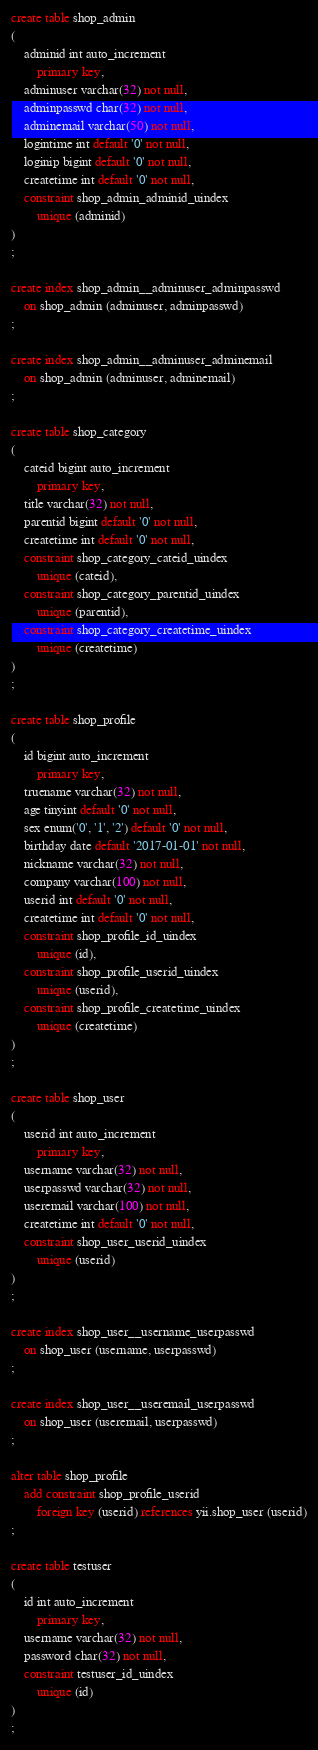<code> <loc_0><loc_0><loc_500><loc_500><_SQL_>create table shop_admin
(
	adminid int auto_increment
		primary key,
	adminuser varchar(32) not null,
	adminpasswd char(32) not null,
	adminemail varchar(50) not null,
	logintime int default '0' not null,
	loginip bigint default '0' not null,
	createtime int default '0' not null,
	constraint shop_admin_adminid_uindex
		unique (adminid)
)
;

create index shop_admin__adminuser_adminpasswd
	on shop_admin (adminuser, adminpasswd)
;

create index shop_admin__adminuser_adminemail
	on shop_admin (adminuser, adminemail)
;

create table shop_category
(
	cateid bigint auto_increment
		primary key,
	title varchar(32) not null,
	parentid bigint default '0' not null,
	createtime int default '0' not null,
	constraint shop_category_cateid_uindex
		unique (cateid),
	constraint shop_category_parentid_uindex
		unique (parentid),
	constraint shop_category_createtime_uindex
		unique (createtime)
)
;

create table shop_profile
(
	id bigint auto_increment
		primary key,
	truename varchar(32) not null,
	age tinyint default '0' not null,
	sex enum('0', '1', '2') default '0' not null,
	birthday date default '2017-01-01' not null,
	nickname varchar(32) not null,
	company varchar(100) not null,
	userid int default '0' not null,
	createtime int default '0' not null,
	constraint shop_profile_id_uindex
		unique (id),
	constraint shop_profile_userid_uindex
		unique (userid),
	constraint shop_profile_createtime_uindex
		unique (createtime)
)
;

create table shop_user
(
	userid int auto_increment
		primary key,
	username varchar(32) not null,
	userpasswd varchar(32) not null,
	useremail varchar(100) not null,
	createtime int default '0' not null,
	constraint shop_user_userid_uindex
		unique (userid)
)
;

create index shop_user__username_userpasswd
	on shop_user (username, userpasswd)
;

create index shop_user__useremail_userpasswd
	on shop_user (useremail, userpasswd)
;

alter table shop_profile
	add constraint shop_profile_userid
		foreign key (userid) references yii.shop_user (userid)
;

create table testuser
(
	id int auto_increment
		primary key,
	username varchar(32) not null,
	password char(32) not null,
	constraint testuser_id_uindex
		unique (id)
)
;

</code> 